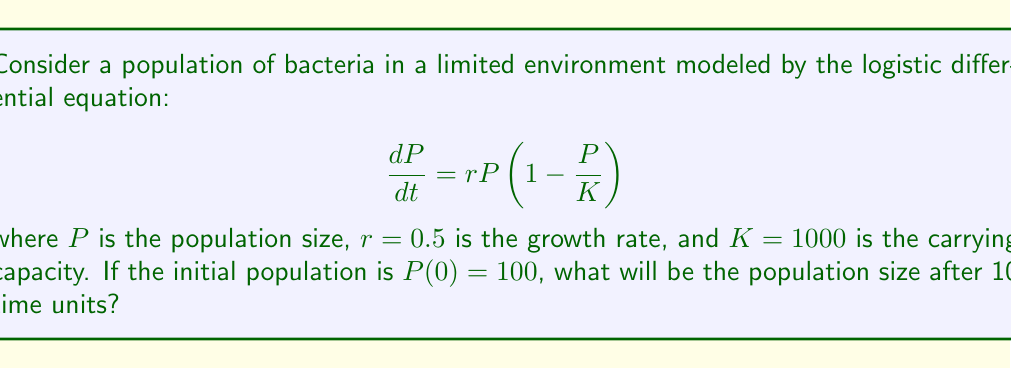What is the answer to this math problem? To solve this problem, we need to follow these steps:

1) The logistic differential equation has the general solution:

   $$P(t) = \frac{K}{1 + \left(\frac{K}{P_0} - 1\right)e^{-rt}}$$

   where $P_0$ is the initial population.

2) We are given:
   $K = 1000$ (carrying capacity)
   $r = 0.5$ (growth rate)
   $P_0 = 100$ (initial population)
   $t = 10$ (time)

3) Let's substitute these values into the equation:

   $$P(10) = \frac{1000}{1 + \left(\frac{1000}{100} - 1\right)e^{-0.5 \cdot 10}}$$

4) Simplify inside the parentheses:

   $$P(10) = \frac{1000}{1 + (10 - 1)e^{-5}}$$

5) Calculate $e^{-5}$:

   $$P(10) = \frac{1000}{1 + 9 \cdot 0.00674}$$

6) Multiply:

   $$P(10) = \frac{1000}{1 + 0.06066}$$

7) Add in the denominator:

   $$P(10) = \frac{1000}{1.06066}$$

8) Divide:

   $$P(10) \approx 942.83$$

9) Round to the nearest whole number as we're dealing with a population:

   $$P(10) \approx 943$$
Answer: 943 bacteria 